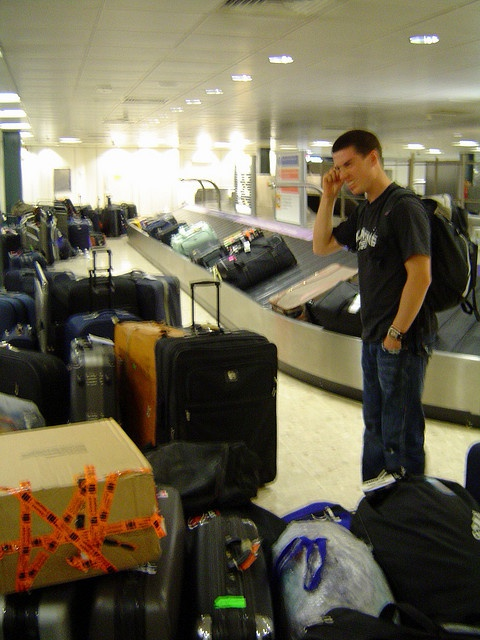Describe the objects in this image and their specific colors. I can see suitcase in gray, black, olive, and tan tones, people in gray, black, and olive tones, suitcase in gray, black, tan, khaki, and olive tones, suitcase in gray, black, darkgreen, and lime tones, and backpack in gray, black, and darkgreen tones in this image. 